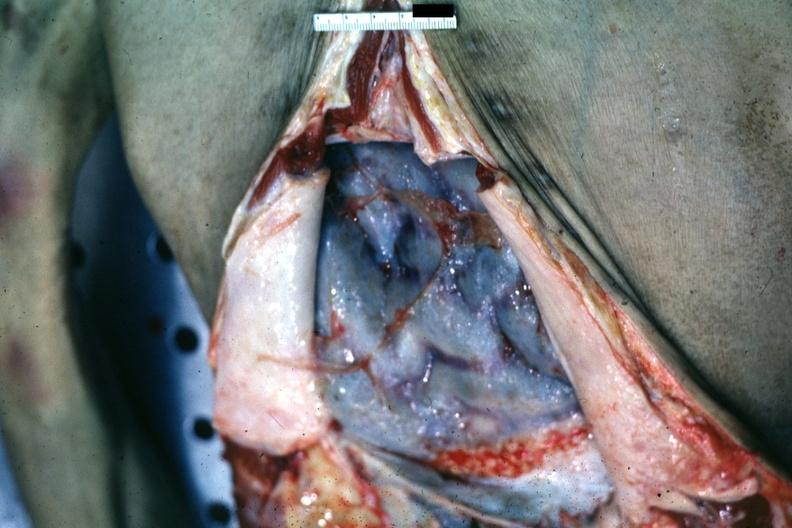s an opened peritoneal cavity cause by fibrous band strangulation present?
Answer the question using a single word or phrase. No 